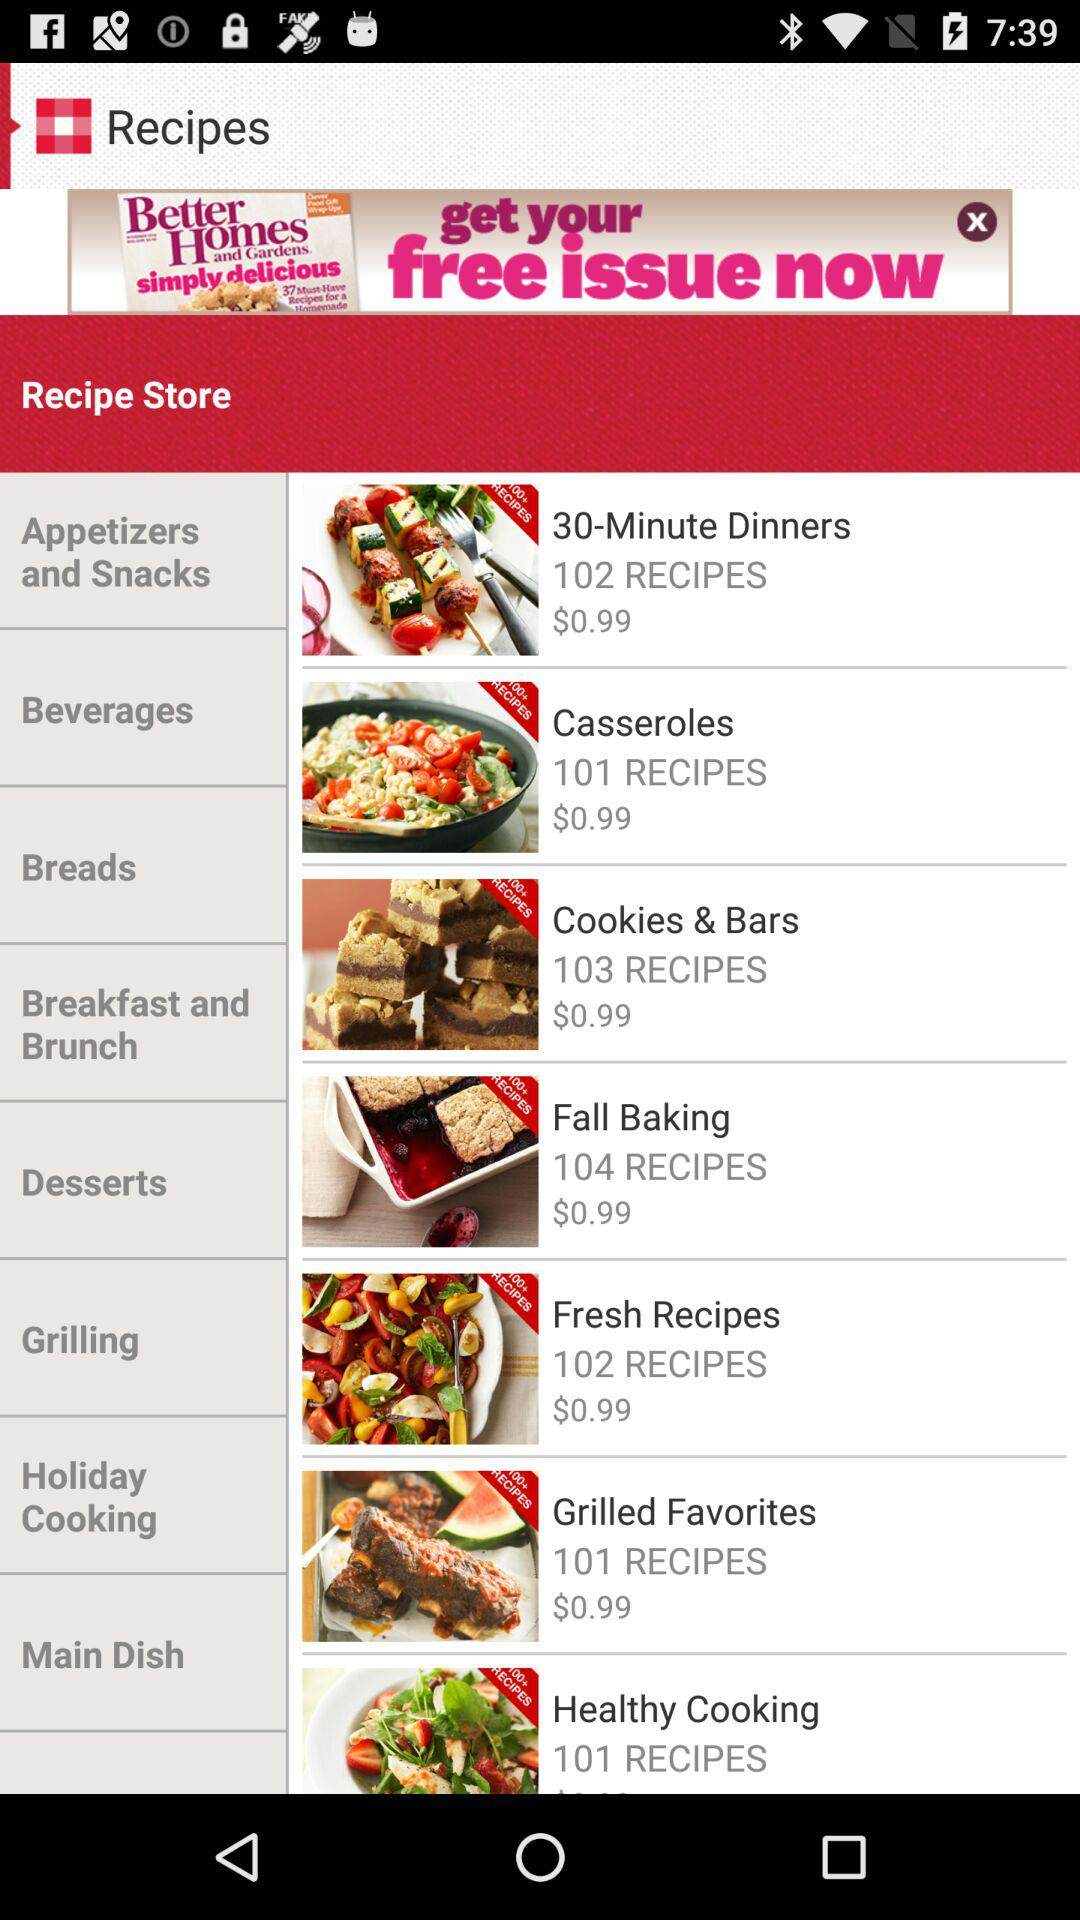How much is the price of the "Cookies & Bars"? The price of the "Cookies & Bars" is $0.99. 